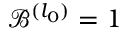<formula> <loc_0><loc_0><loc_500><loc_500>\mathcal { B } ^ { ( l _ { 0 } ) } = 1</formula> 